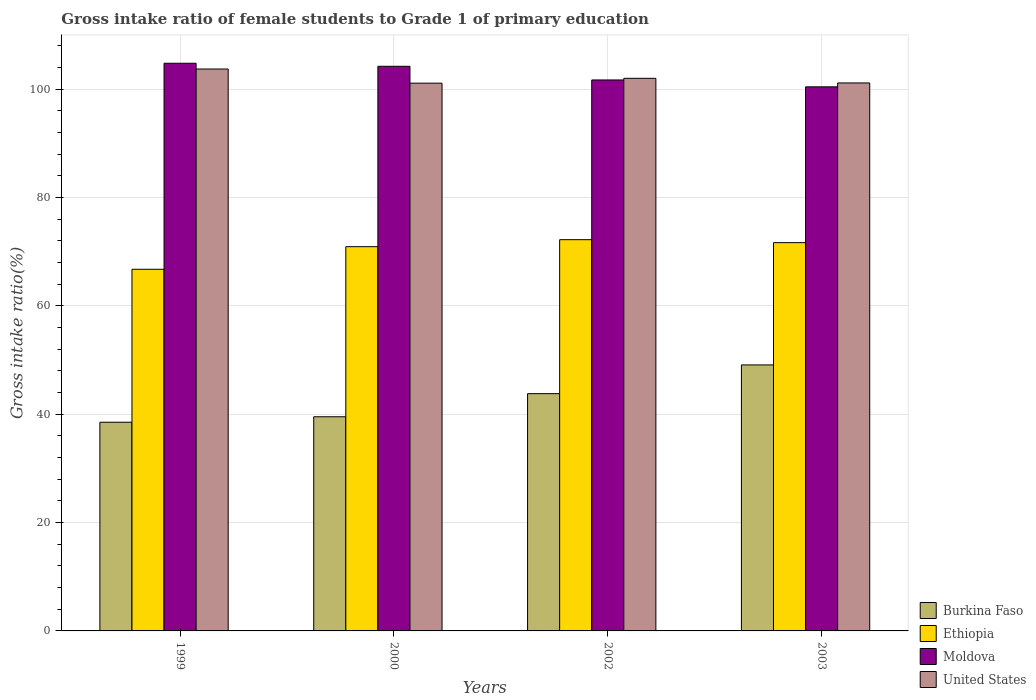How many bars are there on the 4th tick from the left?
Provide a succinct answer. 4. What is the label of the 1st group of bars from the left?
Make the answer very short. 1999. In how many cases, is the number of bars for a given year not equal to the number of legend labels?
Keep it short and to the point. 0. What is the gross intake ratio in United States in 1999?
Give a very brief answer. 103.7. Across all years, what is the maximum gross intake ratio in Ethiopia?
Your answer should be compact. 72.21. Across all years, what is the minimum gross intake ratio in Ethiopia?
Your response must be concise. 66.74. In which year was the gross intake ratio in United States maximum?
Give a very brief answer. 1999. In which year was the gross intake ratio in Moldova minimum?
Give a very brief answer. 2003. What is the total gross intake ratio in United States in the graph?
Offer a terse response. 407.9. What is the difference between the gross intake ratio in Ethiopia in 1999 and that in 2003?
Offer a very short reply. -4.91. What is the difference between the gross intake ratio in Ethiopia in 2003 and the gross intake ratio in Burkina Faso in 2002?
Provide a short and direct response. 27.87. What is the average gross intake ratio in Moldova per year?
Ensure brevity in your answer.  102.76. In the year 2003, what is the difference between the gross intake ratio in Moldova and gross intake ratio in Burkina Faso?
Your response must be concise. 51.32. What is the ratio of the gross intake ratio in Ethiopia in 1999 to that in 2002?
Give a very brief answer. 0.92. Is the difference between the gross intake ratio in Moldova in 2000 and 2003 greater than the difference between the gross intake ratio in Burkina Faso in 2000 and 2003?
Provide a succinct answer. Yes. What is the difference between the highest and the second highest gross intake ratio in Ethiopia?
Make the answer very short. 0.55. What is the difference between the highest and the lowest gross intake ratio in Ethiopia?
Ensure brevity in your answer.  5.46. Is it the case that in every year, the sum of the gross intake ratio in Burkina Faso and gross intake ratio in Ethiopia is greater than the sum of gross intake ratio in Moldova and gross intake ratio in United States?
Your answer should be compact. Yes. What does the 3rd bar from the right in 2002 represents?
Provide a short and direct response. Ethiopia. Is it the case that in every year, the sum of the gross intake ratio in Burkina Faso and gross intake ratio in Ethiopia is greater than the gross intake ratio in Moldova?
Ensure brevity in your answer.  Yes. How many bars are there?
Your answer should be compact. 16. Are all the bars in the graph horizontal?
Provide a succinct answer. No. Where does the legend appear in the graph?
Provide a succinct answer. Bottom right. What is the title of the graph?
Provide a short and direct response. Gross intake ratio of female students to Grade 1 of primary education. Does "Togo" appear as one of the legend labels in the graph?
Your answer should be very brief. No. What is the label or title of the X-axis?
Your answer should be compact. Years. What is the label or title of the Y-axis?
Offer a very short reply. Gross intake ratio(%). What is the Gross intake ratio(%) in Burkina Faso in 1999?
Your response must be concise. 38.52. What is the Gross intake ratio(%) in Ethiopia in 1999?
Keep it short and to the point. 66.74. What is the Gross intake ratio(%) of Moldova in 1999?
Ensure brevity in your answer.  104.76. What is the Gross intake ratio(%) in United States in 1999?
Offer a terse response. 103.7. What is the Gross intake ratio(%) of Burkina Faso in 2000?
Provide a succinct answer. 39.52. What is the Gross intake ratio(%) of Ethiopia in 2000?
Offer a very short reply. 70.91. What is the Gross intake ratio(%) of Moldova in 2000?
Make the answer very short. 104.2. What is the Gross intake ratio(%) of United States in 2000?
Make the answer very short. 101.09. What is the Gross intake ratio(%) of Burkina Faso in 2002?
Offer a very short reply. 43.79. What is the Gross intake ratio(%) of Ethiopia in 2002?
Provide a succinct answer. 72.21. What is the Gross intake ratio(%) in Moldova in 2002?
Your response must be concise. 101.68. What is the Gross intake ratio(%) of United States in 2002?
Make the answer very short. 101.98. What is the Gross intake ratio(%) in Burkina Faso in 2003?
Keep it short and to the point. 49.09. What is the Gross intake ratio(%) in Ethiopia in 2003?
Your response must be concise. 71.66. What is the Gross intake ratio(%) of Moldova in 2003?
Offer a very short reply. 100.41. What is the Gross intake ratio(%) in United States in 2003?
Your answer should be compact. 101.13. Across all years, what is the maximum Gross intake ratio(%) of Burkina Faso?
Provide a short and direct response. 49.09. Across all years, what is the maximum Gross intake ratio(%) of Ethiopia?
Your response must be concise. 72.21. Across all years, what is the maximum Gross intake ratio(%) in Moldova?
Offer a very short reply. 104.76. Across all years, what is the maximum Gross intake ratio(%) in United States?
Give a very brief answer. 103.7. Across all years, what is the minimum Gross intake ratio(%) in Burkina Faso?
Your response must be concise. 38.52. Across all years, what is the minimum Gross intake ratio(%) in Ethiopia?
Make the answer very short. 66.74. Across all years, what is the minimum Gross intake ratio(%) of Moldova?
Your answer should be compact. 100.41. Across all years, what is the minimum Gross intake ratio(%) of United States?
Offer a very short reply. 101.09. What is the total Gross intake ratio(%) in Burkina Faso in the graph?
Ensure brevity in your answer.  170.92. What is the total Gross intake ratio(%) in Ethiopia in the graph?
Offer a very short reply. 281.52. What is the total Gross intake ratio(%) of Moldova in the graph?
Make the answer very short. 411.06. What is the total Gross intake ratio(%) in United States in the graph?
Give a very brief answer. 407.9. What is the difference between the Gross intake ratio(%) in Burkina Faso in 1999 and that in 2000?
Your answer should be compact. -1.01. What is the difference between the Gross intake ratio(%) of Ethiopia in 1999 and that in 2000?
Your answer should be compact. -4.17. What is the difference between the Gross intake ratio(%) of Moldova in 1999 and that in 2000?
Make the answer very short. 0.56. What is the difference between the Gross intake ratio(%) in United States in 1999 and that in 2000?
Offer a terse response. 2.61. What is the difference between the Gross intake ratio(%) of Burkina Faso in 1999 and that in 2002?
Provide a succinct answer. -5.27. What is the difference between the Gross intake ratio(%) of Ethiopia in 1999 and that in 2002?
Offer a terse response. -5.46. What is the difference between the Gross intake ratio(%) of Moldova in 1999 and that in 2002?
Give a very brief answer. 3.08. What is the difference between the Gross intake ratio(%) of United States in 1999 and that in 2002?
Offer a terse response. 1.72. What is the difference between the Gross intake ratio(%) of Burkina Faso in 1999 and that in 2003?
Your answer should be very brief. -10.58. What is the difference between the Gross intake ratio(%) of Ethiopia in 1999 and that in 2003?
Your answer should be very brief. -4.91. What is the difference between the Gross intake ratio(%) in Moldova in 1999 and that in 2003?
Give a very brief answer. 4.35. What is the difference between the Gross intake ratio(%) of United States in 1999 and that in 2003?
Offer a very short reply. 2.57. What is the difference between the Gross intake ratio(%) in Burkina Faso in 2000 and that in 2002?
Give a very brief answer. -4.26. What is the difference between the Gross intake ratio(%) in Ethiopia in 2000 and that in 2002?
Offer a terse response. -1.29. What is the difference between the Gross intake ratio(%) of Moldova in 2000 and that in 2002?
Ensure brevity in your answer.  2.52. What is the difference between the Gross intake ratio(%) of United States in 2000 and that in 2002?
Your answer should be compact. -0.9. What is the difference between the Gross intake ratio(%) of Burkina Faso in 2000 and that in 2003?
Your response must be concise. -9.57. What is the difference between the Gross intake ratio(%) of Ethiopia in 2000 and that in 2003?
Offer a terse response. -0.74. What is the difference between the Gross intake ratio(%) in Moldova in 2000 and that in 2003?
Ensure brevity in your answer.  3.79. What is the difference between the Gross intake ratio(%) in United States in 2000 and that in 2003?
Your answer should be compact. -0.04. What is the difference between the Gross intake ratio(%) in Burkina Faso in 2002 and that in 2003?
Your answer should be very brief. -5.3. What is the difference between the Gross intake ratio(%) of Ethiopia in 2002 and that in 2003?
Your answer should be very brief. 0.55. What is the difference between the Gross intake ratio(%) in Moldova in 2002 and that in 2003?
Your answer should be very brief. 1.27. What is the difference between the Gross intake ratio(%) in United States in 2002 and that in 2003?
Give a very brief answer. 0.85. What is the difference between the Gross intake ratio(%) in Burkina Faso in 1999 and the Gross intake ratio(%) in Ethiopia in 2000?
Make the answer very short. -32.4. What is the difference between the Gross intake ratio(%) of Burkina Faso in 1999 and the Gross intake ratio(%) of Moldova in 2000?
Your answer should be very brief. -65.69. What is the difference between the Gross intake ratio(%) in Burkina Faso in 1999 and the Gross intake ratio(%) in United States in 2000?
Your answer should be compact. -62.57. What is the difference between the Gross intake ratio(%) in Ethiopia in 1999 and the Gross intake ratio(%) in Moldova in 2000?
Keep it short and to the point. -37.46. What is the difference between the Gross intake ratio(%) in Ethiopia in 1999 and the Gross intake ratio(%) in United States in 2000?
Your answer should be compact. -34.34. What is the difference between the Gross intake ratio(%) in Moldova in 1999 and the Gross intake ratio(%) in United States in 2000?
Offer a very short reply. 3.67. What is the difference between the Gross intake ratio(%) in Burkina Faso in 1999 and the Gross intake ratio(%) in Ethiopia in 2002?
Provide a succinct answer. -33.69. What is the difference between the Gross intake ratio(%) in Burkina Faso in 1999 and the Gross intake ratio(%) in Moldova in 2002?
Keep it short and to the point. -63.16. What is the difference between the Gross intake ratio(%) of Burkina Faso in 1999 and the Gross intake ratio(%) of United States in 2002?
Provide a short and direct response. -63.47. What is the difference between the Gross intake ratio(%) in Ethiopia in 1999 and the Gross intake ratio(%) in Moldova in 2002?
Your answer should be compact. -34.94. What is the difference between the Gross intake ratio(%) of Ethiopia in 1999 and the Gross intake ratio(%) of United States in 2002?
Make the answer very short. -35.24. What is the difference between the Gross intake ratio(%) of Moldova in 1999 and the Gross intake ratio(%) of United States in 2002?
Give a very brief answer. 2.78. What is the difference between the Gross intake ratio(%) in Burkina Faso in 1999 and the Gross intake ratio(%) in Ethiopia in 2003?
Ensure brevity in your answer.  -33.14. What is the difference between the Gross intake ratio(%) of Burkina Faso in 1999 and the Gross intake ratio(%) of Moldova in 2003?
Offer a terse response. -61.9. What is the difference between the Gross intake ratio(%) of Burkina Faso in 1999 and the Gross intake ratio(%) of United States in 2003?
Ensure brevity in your answer.  -62.61. What is the difference between the Gross intake ratio(%) of Ethiopia in 1999 and the Gross intake ratio(%) of Moldova in 2003?
Offer a very short reply. -33.67. What is the difference between the Gross intake ratio(%) of Ethiopia in 1999 and the Gross intake ratio(%) of United States in 2003?
Provide a succinct answer. -34.39. What is the difference between the Gross intake ratio(%) of Moldova in 1999 and the Gross intake ratio(%) of United States in 2003?
Your response must be concise. 3.63. What is the difference between the Gross intake ratio(%) in Burkina Faso in 2000 and the Gross intake ratio(%) in Ethiopia in 2002?
Give a very brief answer. -32.68. What is the difference between the Gross intake ratio(%) in Burkina Faso in 2000 and the Gross intake ratio(%) in Moldova in 2002?
Provide a short and direct response. -62.16. What is the difference between the Gross intake ratio(%) of Burkina Faso in 2000 and the Gross intake ratio(%) of United States in 2002?
Keep it short and to the point. -62.46. What is the difference between the Gross intake ratio(%) of Ethiopia in 2000 and the Gross intake ratio(%) of Moldova in 2002?
Your response must be concise. -30.77. What is the difference between the Gross intake ratio(%) of Ethiopia in 2000 and the Gross intake ratio(%) of United States in 2002?
Your answer should be compact. -31.07. What is the difference between the Gross intake ratio(%) of Moldova in 2000 and the Gross intake ratio(%) of United States in 2002?
Ensure brevity in your answer.  2.22. What is the difference between the Gross intake ratio(%) of Burkina Faso in 2000 and the Gross intake ratio(%) of Ethiopia in 2003?
Your response must be concise. -32.13. What is the difference between the Gross intake ratio(%) in Burkina Faso in 2000 and the Gross intake ratio(%) in Moldova in 2003?
Your response must be concise. -60.89. What is the difference between the Gross intake ratio(%) of Burkina Faso in 2000 and the Gross intake ratio(%) of United States in 2003?
Give a very brief answer. -61.61. What is the difference between the Gross intake ratio(%) in Ethiopia in 2000 and the Gross intake ratio(%) in Moldova in 2003?
Provide a succinct answer. -29.5. What is the difference between the Gross intake ratio(%) of Ethiopia in 2000 and the Gross intake ratio(%) of United States in 2003?
Your answer should be compact. -30.22. What is the difference between the Gross intake ratio(%) in Moldova in 2000 and the Gross intake ratio(%) in United States in 2003?
Give a very brief answer. 3.07. What is the difference between the Gross intake ratio(%) of Burkina Faso in 2002 and the Gross intake ratio(%) of Ethiopia in 2003?
Provide a short and direct response. -27.87. What is the difference between the Gross intake ratio(%) in Burkina Faso in 2002 and the Gross intake ratio(%) in Moldova in 2003?
Give a very brief answer. -56.62. What is the difference between the Gross intake ratio(%) of Burkina Faso in 2002 and the Gross intake ratio(%) of United States in 2003?
Provide a succinct answer. -57.34. What is the difference between the Gross intake ratio(%) in Ethiopia in 2002 and the Gross intake ratio(%) in Moldova in 2003?
Keep it short and to the point. -28.21. What is the difference between the Gross intake ratio(%) in Ethiopia in 2002 and the Gross intake ratio(%) in United States in 2003?
Keep it short and to the point. -28.92. What is the difference between the Gross intake ratio(%) of Moldova in 2002 and the Gross intake ratio(%) of United States in 2003?
Give a very brief answer. 0.55. What is the average Gross intake ratio(%) of Burkina Faso per year?
Your response must be concise. 42.73. What is the average Gross intake ratio(%) in Ethiopia per year?
Keep it short and to the point. 70.38. What is the average Gross intake ratio(%) of Moldova per year?
Provide a succinct answer. 102.76. What is the average Gross intake ratio(%) of United States per year?
Keep it short and to the point. 101.98. In the year 1999, what is the difference between the Gross intake ratio(%) of Burkina Faso and Gross intake ratio(%) of Ethiopia?
Provide a succinct answer. -28.23. In the year 1999, what is the difference between the Gross intake ratio(%) of Burkina Faso and Gross intake ratio(%) of Moldova?
Keep it short and to the point. -66.25. In the year 1999, what is the difference between the Gross intake ratio(%) of Burkina Faso and Gross intake ratio(%) of United States?
Make the answer very short. -65.19. In the year 1999, what is the difference between the Gross intake ratio(%) in Ethiopia and Gross intake ratio(%) in Moldova?
Keep it short and to the point. -38.02. In the year 1999, what is the difference between the Gross intake ratio(%) in Ethiopia and Gross intake ratio(%) in United States?
Make the answer very short. -36.96. In the year 1999, what is the difference between the Gross intake ratio(%) of Moldova and Gross intake ratio(%) of United States?
Your answer should be compact. 1.06. In the year 2000, what is the difference between the Gross intake ratio(%) of Burkina Faso and Gross intake ratio(%) of Ethiopia?
Provide a succinct answer. -31.39. In the year 2000, what is the difference between the Gross intake ratio(%) of Burkina Faso and Gross intake ratio(%) of Moldova?
Your answer should be very brief. -64.68. In the year 2000, what is the difference between the Gross intake ratio(%) of Burkina Faso and Gross intake ratio(%) of United States?
Ensure brevity in your answer.  -61.56. In the year 2000, what is the difference between the Gross intake ratio(%) in Ethiopia and Gross intake ratio(%) in Moldova?
Provide a short and direct response. -33.29. In the year 2000, what is the difference between the Gross intake ratio(%) in Ethiopia and Gross intake ratio(%) in United States?
Give a very brief answer. -30.18. In the year 2000, what is the difference between the Gross intake ratio(%) of Moldova and Gross intake ratio(%) of United States?
Your answer should be very brief. 3.11. In the year 2002, what is the difference between the Gross intake ratio(%) of Burkina Faso and Gross intake ratio(%) of Ethiopia?
Offer a very short reply. -28.42. In the year 2002, what is the difference between the Gross intake ratio(%) of Burkina Faso and Gross intake ratio(%) of Moldova?
Keep it short and to the point. -57.89. In the year 2002, what is the difference between the Gross intake ratio(%) of Burkina Faso and Gross intake ratio(%) of United States?
Provide a succinct answer. -58.2. In the year 2002, what is the difference between the Gross intake ratio(%) of Ethiopia and Gross intake ratio(%) of Moldova?
Give a very brief answer. -29.47. In the year 2002, what is the difference between the Gross intake ratio(%) of Ethiopia and Gross intake ratio(%) of United States?
Keep it short and to the point. -29.78. In the year 2002, what is the difference between the Gross intake ratio(%) of Moldova and Gross intake ratio(%) of United States?
Give a very brief answer. -0.3. In the year 2003, what is the difference between the Gross intake ratio(%) of Burkina Faso and Gross intake ratio(%) of Ethiopia?
Make the answer very short. -22.56. In the year 2003, what is the difference between the Gross intake ratio(%) in Burkina Faso and Gross intake ratio(%) in Moldova?
Your answer should be compact. -51.32. In the year 2003, what is the difference between the Gross intake ratio(%) of Burkina Faso and Gross intake ratio(%) of United States?
Give a very brief answer. -52.04. In the year 2003, what is the difference between the Gross intake ratio(%) of Ethiopia and Gross intake ratio(%) of Moldova?
Provide a short and direct response. -28.76. In the year 2003, what is the difference between the Gross intake ratio(%) of Ethiopia and Gross intake ratio(%) of United States?
Provide a short and direct response. -29.47. In the year 2003, what is the difference between the Gross intake ratio(%) of Moldova and Gross intake ratio(%) of United States?
Your answer should be compact. -0.72. What is the ratio of the Gross intake ratio(%) in Burkina Faso in 1999 to that in 2000?
Give a very brief answer. 0.97. What is the ratio of the Gross intake ratio(%) in Moldova in 1999 to that in 2000?
Your answer should be compact. 1.01. What is the ratio of the Gross intake ratio(%) of United States in 1999 to that in 2000?
Provide a succinct answer. 1.03. What is the ratio of the Gross intake ratio(%) of Burkina Faso in 1999 to that in 2002?
Provide a succinct answer. 0.88. What is the ratio of the Gross intake ratio(%) of Ethiopia in 1999 to that in 2002?
Offer a very short reply. 0.92. What is the ratio of the Gross intake ratio(%) of Moldova in 1999 to that in 2002?
Keep it short and to the point. 1.03. What is the ratio of the Gross intake ratio(%) in United States in 1999 to that in 2002?
Your answer should be very brief. 1.02. What is the ratio of the Gross intake ratio(%) of Burkina Faso in 1999 to that in 2003?
Keep it short and to the point. 0.78. What is the ratio of the Gross intake ratio(%) in Ethiopia in 1999 to that in 2003?
Offer a very short reply. 0.93. What is the ratio of the Gross intake ratio(%) of Moldova in 1999 to that in 2003?
Provide a succinct answer. 1.04. What is the ratio of the Gross intake ratio(%) of United States in 1999 to that in 2003?
Offer a terse response. 1.03. What is the ratio of the Gross intake ratio(%) of Burkina Faso in 2000 to that in 2002?
Provide a short and direct response. 0.9. What is the ratio of the Gross intake ratio(%) in Ethiopia in 2000 to that in 2002?
Keep it short and to the point. 0.98. What is the ratio of the Gross intake ratio(%) in Moldova in 2000 to that in 2002?
Provide a short and direct response. 1.02. What is the ratio of the Gross intake ratio(%) of United States in 2000 to that in 2002?
Make the answer very short. 0.99. What is the ratio of the Gross intake ratio(%) in Burkina Faso in 2000 to that in 2003?
Your answer should be compact. 0.81. What is the ratio of the Gross intake ratio(%) of Moldova in 2000 to that in 2003?
Keep it short and to the point. 1.04. What is the ratio of the Gross intake ratio(%) of United States in 2000 to that in 2003?
Make the answer very short. 1. What is the ratio of the Gross intake ratio(%) in Burkina Faso in 2002 to that in 2003?
Keep it short and to the point. 0.89. What is the ratio of the Gross intake ratio(%) in Ethiopia in 2002 to that in 2003?
Keep it short and to the point. 1.01. What is the ratio of the Gross intake ratio(%) in Moldova in 2002 to that in 2003?
Keep it short and to the point. 1.01. What is the ratio of the Gross intake ratio(%) in United States in 2002 to that in 2003?
Your answer should be very brief. 1.01. What is the difference between the highest and the second highest Gross intake ratio(%) in Burkina Faso?
Your answer should be compact. 5.3. What is the difference between the highest and the second highest Gross intake ratio(%) in Ethiopia?
Keep it short and to the point. 0.55. What is the difference between the highest and the second highest Gross intake ratio(%) in Moldova?
Ensure brevity in your answer.  0.56. What is the difference between the highest and the second highest Gross intake ratio(%) of United States?
Provide a short and direct response. 1.72. What is the difference between the highest and the lowest Gross intake ratio(%) of Burkina Faso?
Keep it short and to the point. 10.58. What is the difference between the highest and the lowest Gross intake ratio(%) in Ethiopia?
Ensure brevity in your answer.  5.46. What is the difference between the highest and the lowest Gross intake ratio(%) of Moldova?
Your answer should be very brief. 4.35. What is the difference between the highest and the lowest Gross intake ratio(%) in United States?
Make the answer very short. 2.61. 